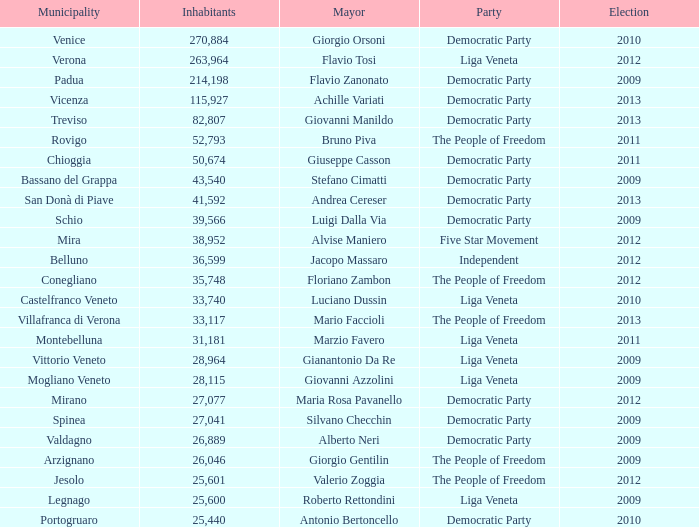What party was achille variati afilliated with? Democratic Party. 